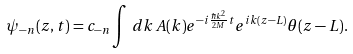Convert formula to latex. <formula><loc_0><loc_0><loc_500><loc_500>\psi _ { - n } ( z , t ) = c _ { - n } \int \, d k \, A ( k ) e ^ { - i \frac { \hbar { k } ^ { 2 } } { 2 M } t } e ^ { i k ( z - L ) } \theta ( z - L ) .</formula> 